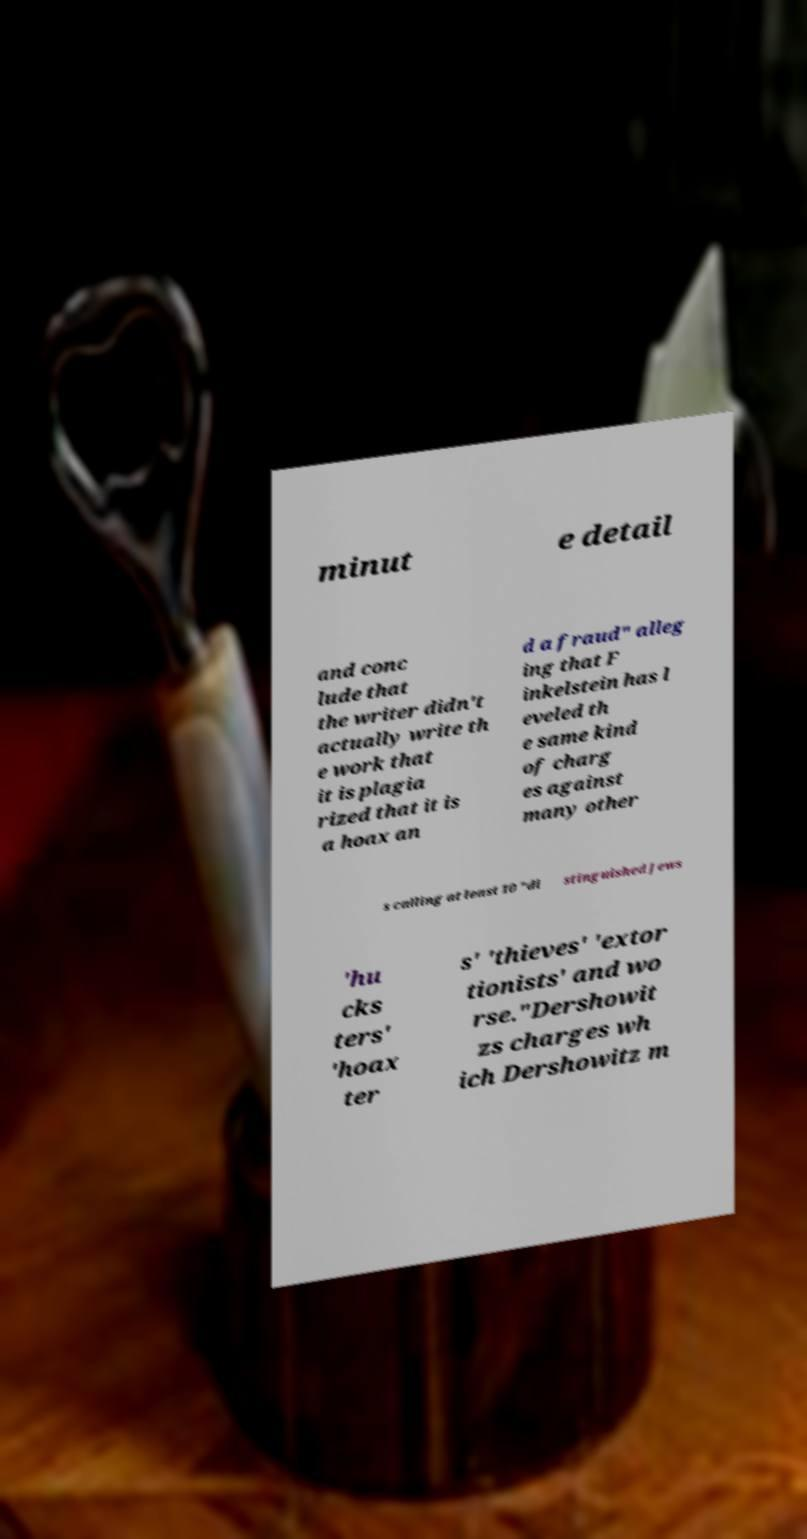Could you extract and type out the text from this image? minut e detail and conc lude that the writer didn't actually write th e work that it is plagia rized that it is a hoax an d a fraud" alleg ing that F inkelstein has l eveled th e same kind of charg es against many other s calling at least 10 "di stinguished Jews 'hu cks ters' 'hoax ter s' 'thieves' 'extor tionists' and wo rse."Dershowit zs charges wh ich Dershowitz m 